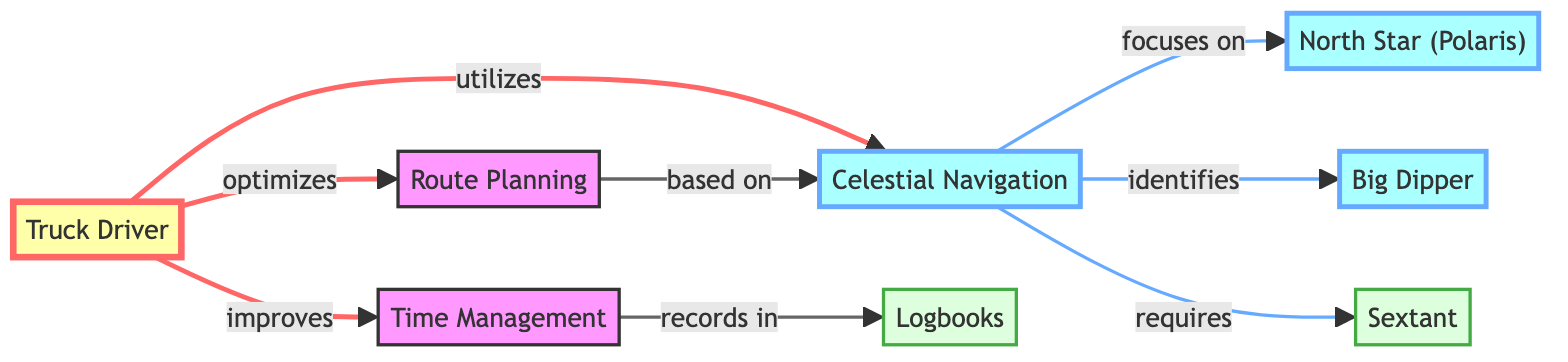What does a truck driver utilize for navigation? The diagram shows that a truck driver utilizes celestial navigation, which is specifically indicated in the flow from the truck driver node to the celestial navigation node.
Answer: celestial navigation Which celestial body is focused on in celestial navigation? According to the diagram, celestial navigation focuses on the North Star (Polaris), as depicted by the direct link from celestial navigation to the North Star node.
Answer: North Star (Polaris) How many tools are mentioned in the diagram? The diagram includes two tools: the sextant and logbooks, which can be counted directly from the nodes marked as tool.
Answer: 2 What does route planning depend on? Route planning is based on celestial navigation, as indicated in the link from the route planning node to the celestial navigation node.
Answer: celestial navigation What do truck drivers improve according to the diagram? The flowchart indicates that truck drivers improve time management, as depicted by the flow from the truck driver to the time management node.
Answer: time management What is required for celestial navigation? The diagram specifies that celestial navigation requires a sextant, which is illustrated by the direct link from the celestial navigation node to the sextant node.
Answer: sextant What is recorded in logbooks? From the diagram, it is clear that time management is recorded in logbooks, showing the direct link from the time management node to logbooks.
Answer: time management How many celestial bodies are identified in celestial navigation? The diagram identifies two celestial bodies: the North Star (Polaris) and the Big Dipper, indicated by the connections in the celestial navigation section.
Answer: 2 